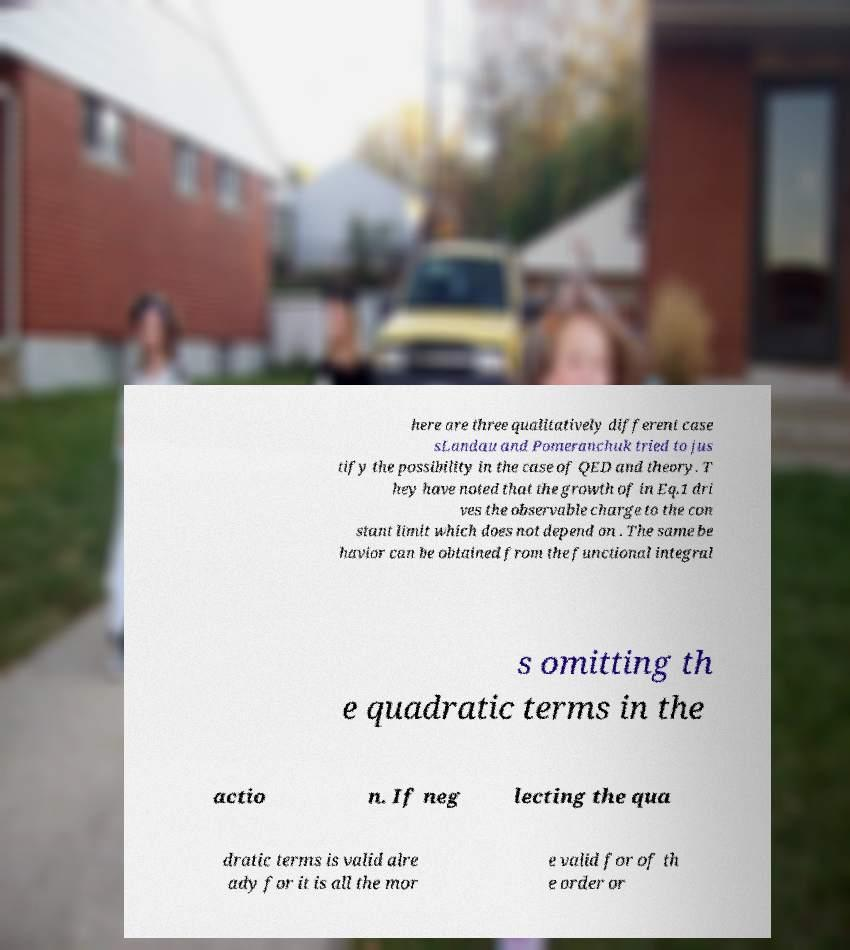Please identify and transcribe the text found in this image. here are three qualitatively different case sLandau and Pomeranchuk tried to jus tify the possibility in the case of QED and theory. T hey have noted that the growth of in Eq.1 dri ves the observable charge to the con stant limit which does not depend on . The same be havior can be obtained from the functional integral s omitting th e quadratic terms in the actio n. If neg lecting the qua dratic terms is valid alre ady for it is all the mor e valid for of th e order or 